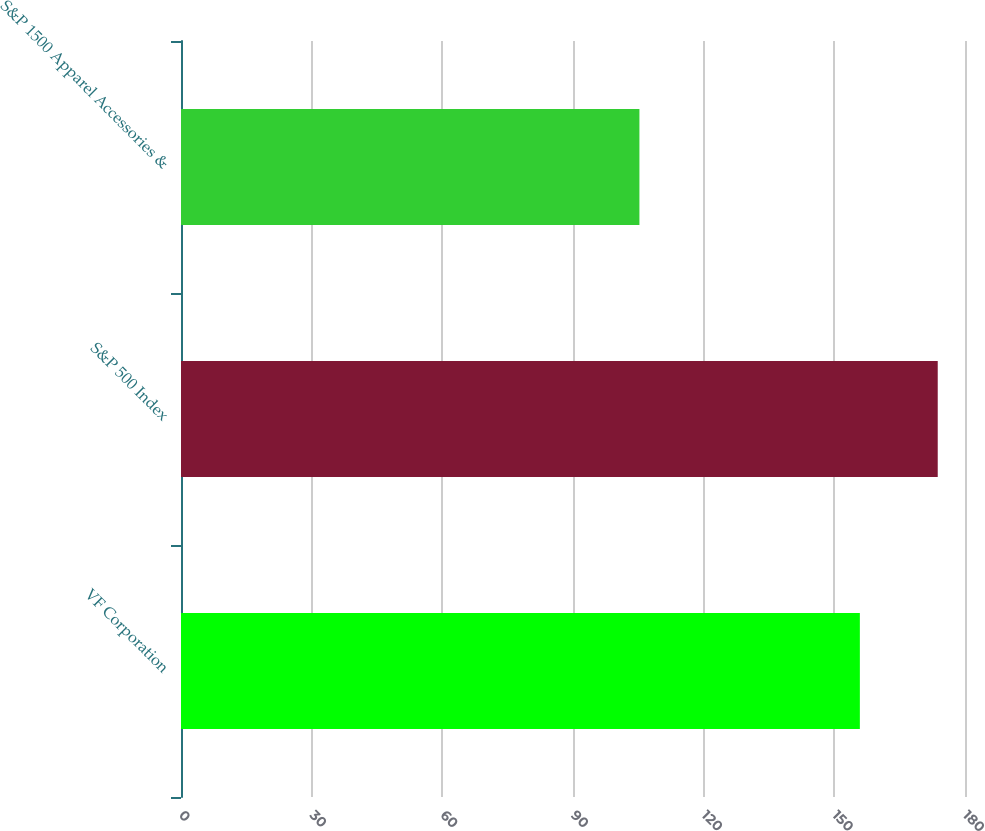<chart> <loc_0><loc_0><loc_500><loc_500><bar_chart><fcel>VF Corporation<fcel>S&P 500 Index<fcel>S&P 1500 Apparel Accessories &<nl><fcel>155.86<fcel>173.74<fcel>105.25<nl></chart> 